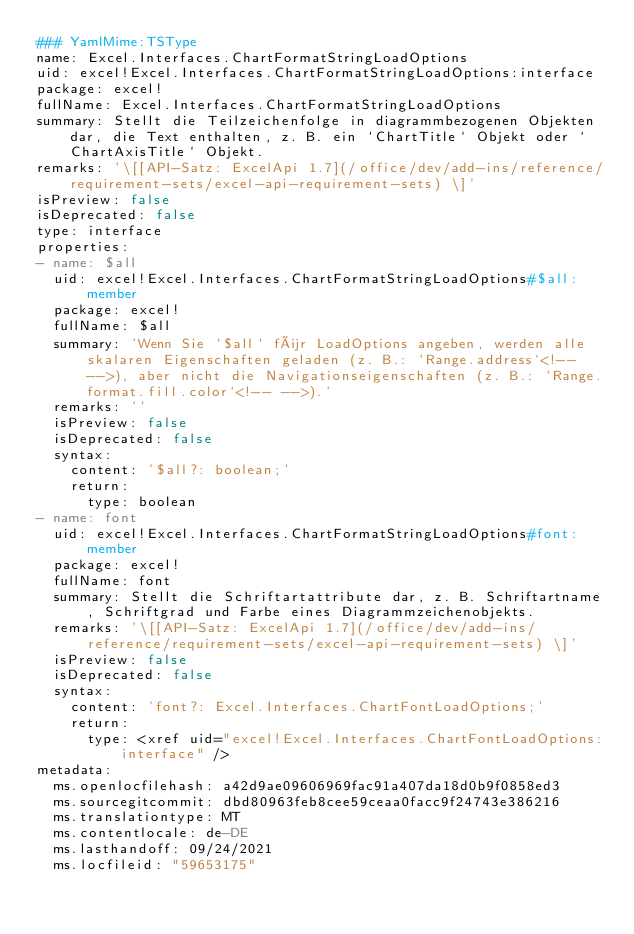<code> <loc_0><loc_0><loc_500><loc_500><_YAML_>### YamlMime:TSType
name: Excel.Interfaces.ChartFormatStringLoadOptions
uid: excel!Excel.Interfaces.ChartFormatStringLoadOptions:interface
package: excel!
fullName: Excel.Interfaces.ChartFormatStringLoadOptions
summary: Stellt die Teilzeichenfolge in diagrammbezogenen Objekten dar, die Text enthalten, z. B. ein `ChartTitle` Objekt oder `ChartAxisTitle` Objekt.
remarks: '\[[API-Satz: ExcelApi 1.7](/office/dev/add-ins/reference/requirement-sets/excel-api-requirement-sets) \]'
isPreview: false
isDeprecated: false
type: interface
properties:
- name: $all
  uid: excel!Excel.Interfaces.ChartFormatStringLoadOptions#$all:member
  package: excel!
  fullName: $all
  summary: 'Wenn Sie `$all` für LoadOptions angeben, werden alle skalaren Eigenschaften geladen (z. B.: `Range.address`<!-- -->), aber nicht die Navigationseigenschaften (z. B.: `Range.format.fill.color`<!-- -->).'
  remarks: ''
  isPreview: false
  isDeprecated: false
  syntax:
    content: '$all?: boolean;'
    return:
      type: boolean
- name: font
  uid: excel!Excel.Interfaces.ChartFormatStringLoadOptions#font:member
  package: excel!
  fullName: font
  summary: Stellt die Schriftartattribute dar, z. B. Schriftartname, Schriftgrad und Farbe eines Diagrammzeichenobjekts.
  remarks: '\[[API-Satz: ExcelApi 1.7](/office/dev/add-ins/reference/requirement-sets/excel-api-requirement-sets) \]'
  isPreview: false
  isDeprecated: false
  syntax:
    content: 'font?: Excel.Interfaces.ChartFontLoadOptions;'
    return:
      type: <xref uid="excel!Excel.Interfaces.ChartFontLoadOptions:interface" />
metadata:
  ms.openlocfilehash: a42d9ae09606969fac91a407da18d0b9f0858ed3
  ms.sourcegitcommit: dbd80963feb8cee59ceaa0facc9f24743e386216
  ms.translationtype: MT
  ms.contentlocale: de-DE
  ms.lasthandoff: 09/24/2021
  ms.locfileid: "59653175"
</code> 